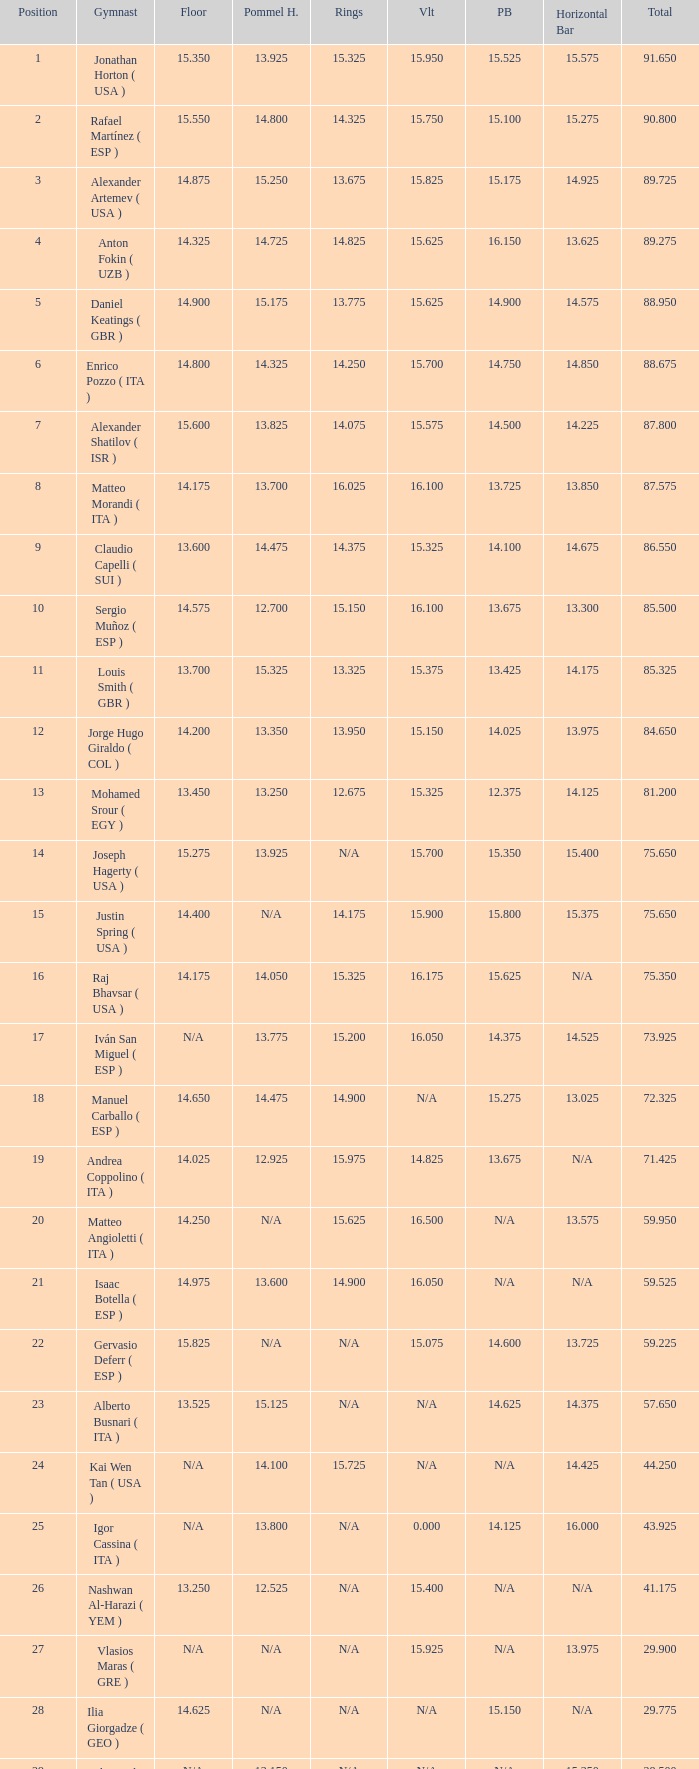If the parallel bars is 16.150, who is the gymnast? Anton Fokin ( UZB ). 